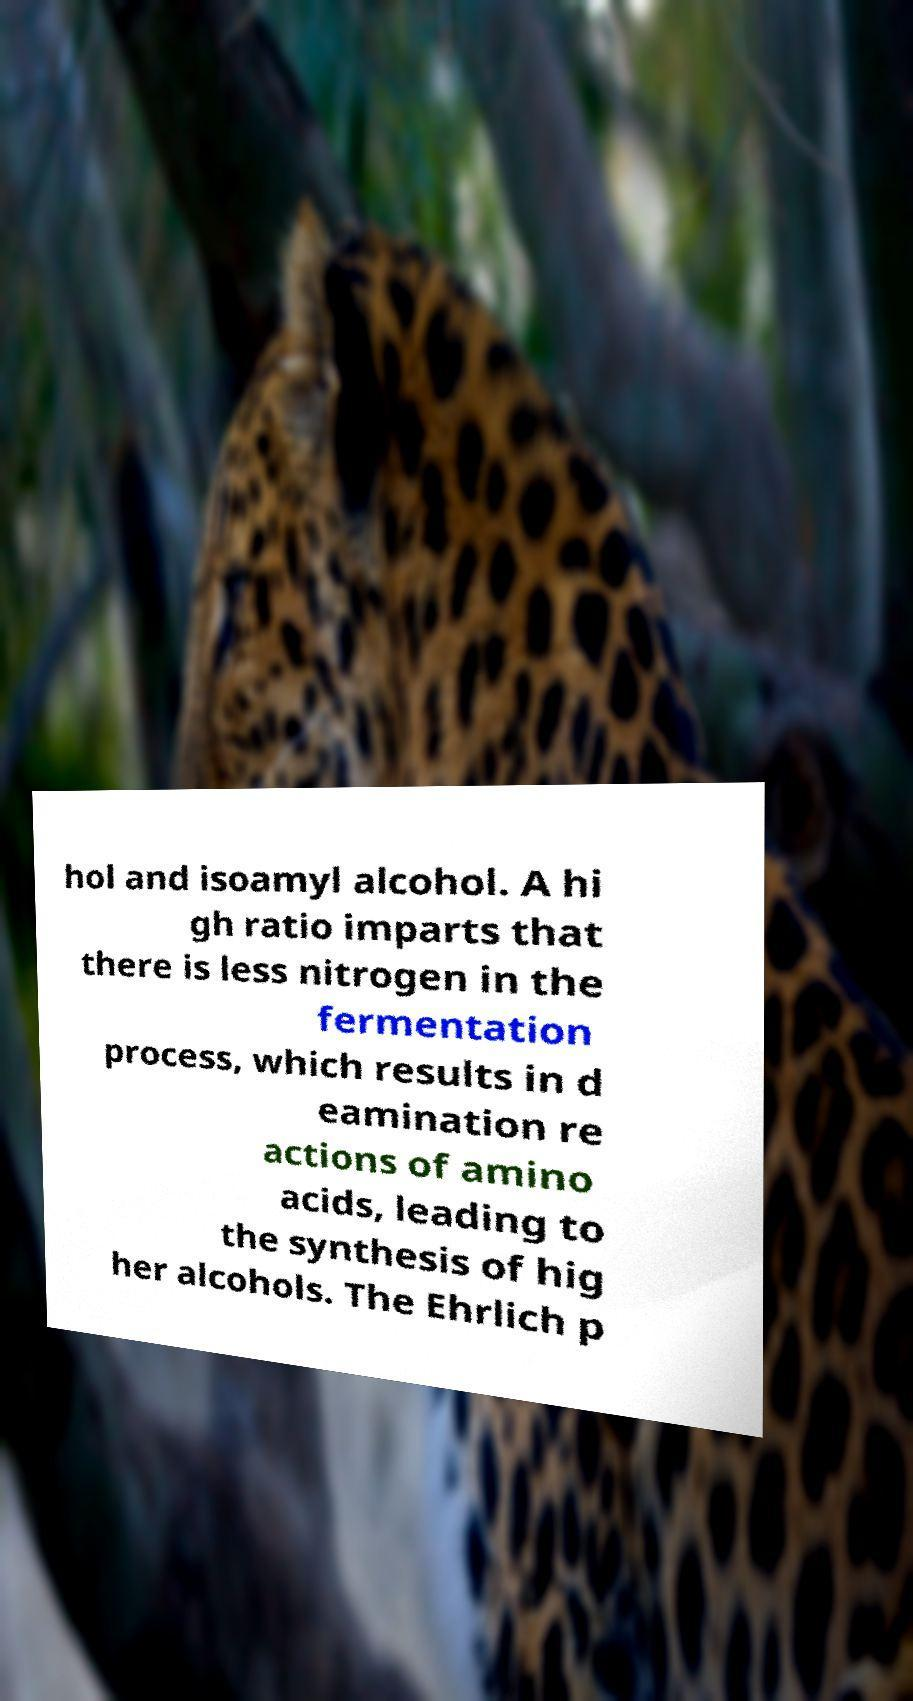Can you read and provide the text displayed in the image?This photo seems to have some interesting text. Can you extract and type it out for me? hol and isoamyl alcohol. A hi gh ratio imparts that there is less nitrogen in the fermentation process, which results in d eamination re actions of amino acids, leading to the synthesis of hig her alcohols. The Ehrlich p 